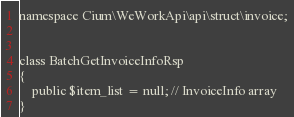Convert code to text. <code><loc_0><loc_0><loc_500><loc_500><_PHP_>namespace Cium\WeWorkApi\api\struct\invoice;


class BatchGetInvoiceInfoRsp
{
    public $item_list = null; // InvoiceInfo array
}</code> 